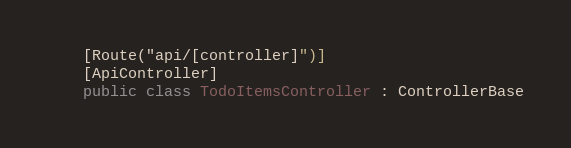<code> <loc_0><loc_0><loc_500><loc_500><_C#_>    [Route("api/[controller]")]
    [ApiController]
    public class TodoItemsController : ControllerBase</code> 